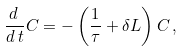<formula> <loc_0><loc_0><loc_500><loc_500>\frac { d \, } { d \, t } C = - \left ( \frac { 1 } { \tau } + \delta L \right ) C \, ,</formula> 